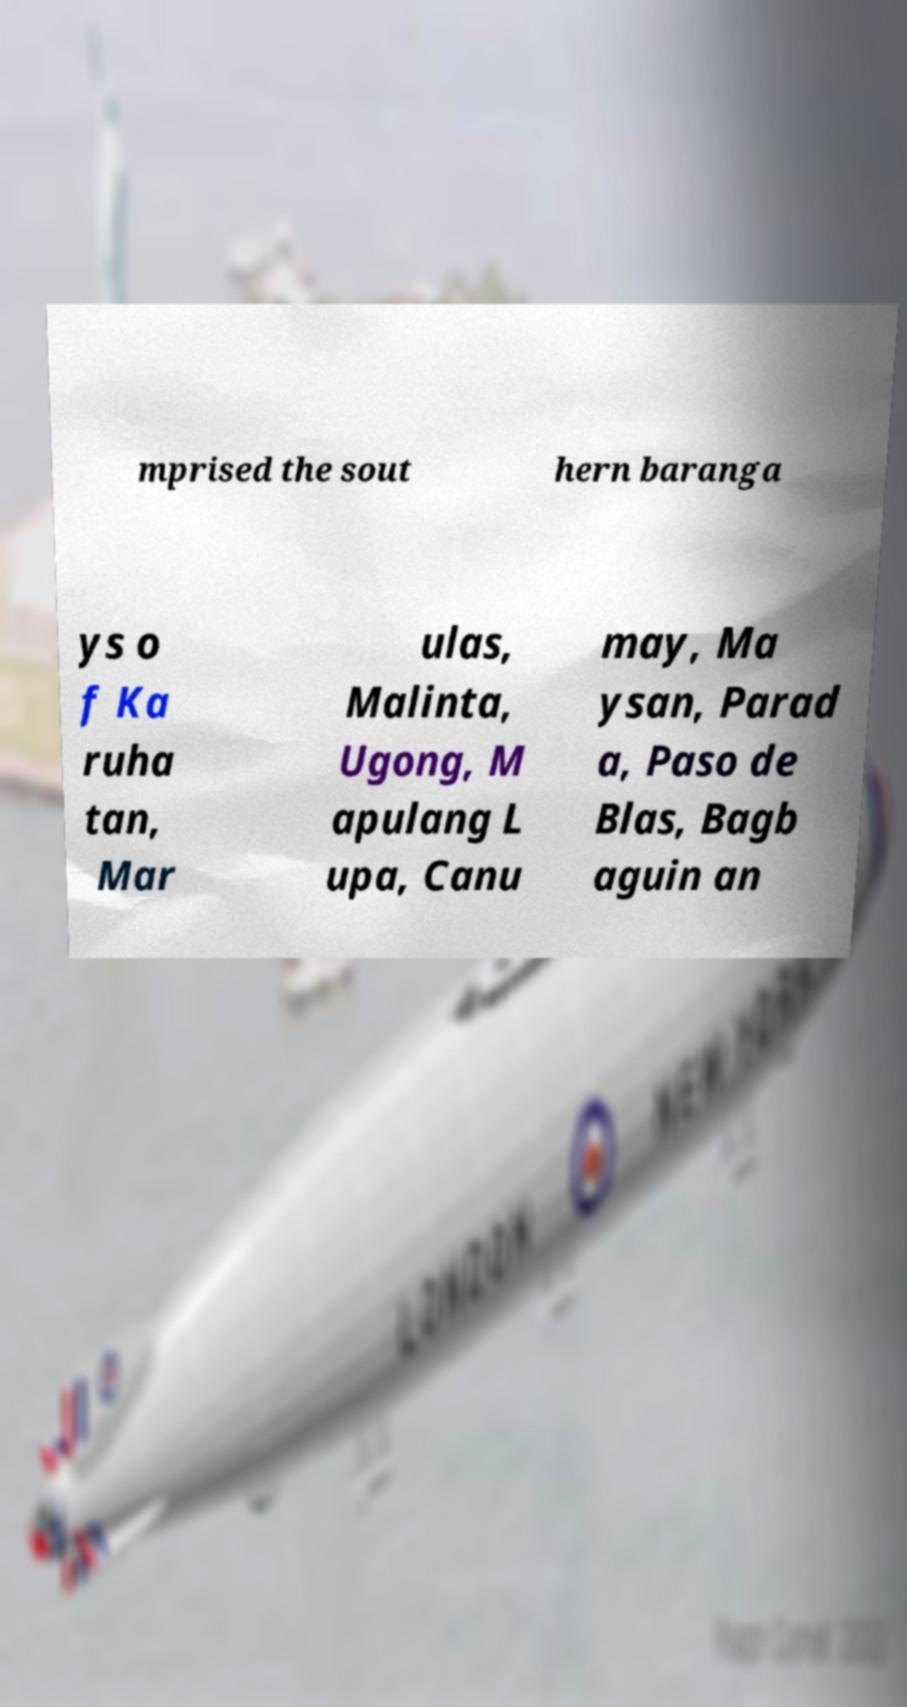Please identify and transcribe the text found in this image. mprised the sout hern baranga ys o f Ka ruha tan, Mar ulas, Malinta, Ugong, M apulang L upa, Canu may, Ma ysan, Parad a, Paso de Blas, Bagb aguin an 